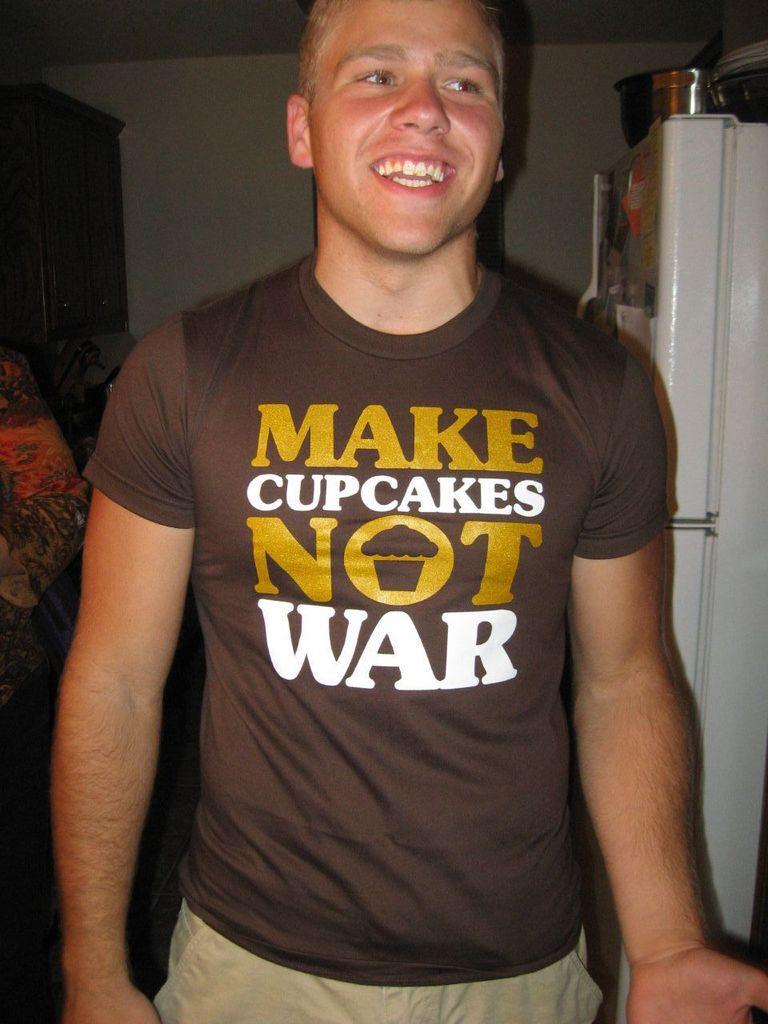What is the saying on the t-shirt?
Provide a succinct answer. Make cupcakes not war. What should be made instead of war?
Your answer should be very brief. Cupcakes. 